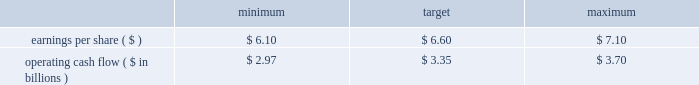The target awards for the other named executive officers were set as follows : joseph f .
Domino , ceo - entergy texas ( 50% ( 50 % ) ) ; hugh t .
Mcdonald , ceo - entergy arkansas ( 50% ( 50 % ) ) ; haley fisackerly , ceo - entergy mississippi ( 40% ( 40 % ) ) ; william m .
Mohl ( 60% ( 60 % ) ) , ceo - entergy gulf states and entergy louisiana ; charles l .
Rice , jr .
( 40% ( 40 % ) ) , ceo - entergy new orleans and theodore h .
Bunting , jr .
- principal accounting officer - the subsidiaries ( 60% ( 60 % ) ) .
The target awards for the named executive officers ( other than entergy named executive officers ) were set by their respective supervisors ( subject to ultimate approval of entergy 2019s chief executive officer ) who allocated a potential incentive pool established by the personnel committee among various of their direct and indirect reports .
In setting the target awards , the supervisor took into account considerations similar to those used by the personnel committee in setting the target awards for entergy 2019s named executive officers .
Target awards are set based on an executive officer 2019s current position and executive management level within the entergy organization .
Executive management levels at entergy range from level 1 thorough level 4 .
Mr .
Denault and mr .
Taylor hold positions in level 2 whereas mr .
Bunting and mr .
Mohl hold positions in level 3 and mr .
Domino , mr .
Fisackerly , mr .
Mcdonald and mr .
Rice hold positions in level 4 .
Accordingly , their respective incentive targets differ one from another based on the external market data developed by the committee 2019s independent compensation consultant and the other factors noted above .
In december 2010 , the committee determined the executive incentive plan targets to be used for purposes of establishing annual bonuses for 2011 .
The committee 2019s determination of the target levels was made after full board review of management 2019s 2011 financial plan for entergy corporation , upon recommendation of the finance committee , and after the committee 2019s determination that the established targets aligned with entergy corporation 2019s anticipated 2011 financial performance as reflected in the financial plan .
The targets established to measure management performance against as reported results were: .
Operating cash flow ( $ in billions ) in january 2012 , after reviewing earnings per share and operating cash flow results against the performance objectives in the above table , the committee determined that entergy corporation had exceeded as reported earnings per share target of $ 6.60 by $ 0.95 in 2011 while falling short of the operating cash flow goal of $ 3.35 billion by $ 221 million in 2011 .
In accordance with the terms of the annual incentive plan , in january 2012 , the personnel committee certified the 2012 entergy achievement multiplier at 128% ( 128 % ) of target .
Under the terms of the management effectiveness program , the entergy achievement multiplier is automatically increased by 25 percent for the members of the office of the chief executive if the pre- established underlying performance goals established by the personnel committee are satisfied at the end of the performance period , subject to the personnel committee's discretion to adjust the automatic multiplier downward or eliminate it altogether .
In accordance with section 162 ( m ) of the internal revenue code , the multiplier which entergy refers to as the management effectiveness factor is intended to provide the committee a mechanism to take into consideration specific achievement factors relating to the overall performance of entergy corporation .
In january 2012 , the committee eliminated the management effectiveness factor with respect to the 2011 incentive awards , reflecting the personnel committee's determination that the entergy achievement multiplier , in and of itself without the management effectiveness factor , was consistent with the performance levels achieved by management .
The annual incentive awards for the named executive officers ( other than mr .
Leonard , mr .
Denault and mr .
Taylor ) are awarded from an incentive pool approved by the committee .
From this pool , each named executive officer 2019s supervisor determines the annual incentive payment based on the entergy achievement multiplier .
The supervisor has the discretion to increase or decrease the multiple used to determine an incentive award based on individual and business unit performance .
The incentive awards are subject to the ultimate approval of entergy 2019s chief executive officer. .
What was the percent of the entergy corporation cash flow shortfall from the target determined in 2011? 
Computations: (221 / 3.35)
Answer: 65.97015. The target awards for the other named executive officers were set as follows : joseph f .
Domino , ceo - entergy texas ( 50% ( 50 % ) ) ; hugh t .
Mcdonald , ceo - entergy arkansas ( 50% ( 50 % ) ) ; haley fisackerly , ceo - entergy mississippi ( 40% ( 40 % ) ) ; william m .
Mohl ( 60% ( 60 % ) ) , ceo - entergy gulf states and entergy louisiana ; charles l .
Rice , jr .
( 40% ( 40 % ) ) , ceo - entergy new orleans and theodore h .
Bunting , jr .
- principal accounting officer - the subsidiaries ( 60% ( 60 % ) ) .
The target awards for the named executive officers ( other than entergy named executive officers ) were set by their respective supervisors ( subject to ultimate approval of entergy 2019s chief executive officer ) who allocated a potential incentive pool established by the personnel committee among various of their direct and indirect reports .
In setting the target awards , the supervisor took into account considerations similar to those used by the personnel committee in setting the target awards for entergy 2019s named executive officers .
Target awards are set based on an executive officer 2019s current position and executive management level within the entergy organization .
Executive management levels at entergy range from level 1 thorough level 4 .
Mr .
Denault and mr .
Taylor hold positions in level 2 whereas mr .
Bunting and mr .
Mohl hold positions in level 3 and mr .
Domino , mr .
Fisackerly , mr .
Mcdonald and mr .
Rice hold positions in level 4 .
Accordingly , their respective incentive targets differ one from another based on the external market data developed by the committee 2019s independent compensation consultant and the other factors noted above .
In december 2010 , the committee determined the executive incentive plan targets to be used for purposes of establishing annual bonuses for 2011 .
The committee 2019s determination of the target levels was made after full board review of management 2019s 2011 financial plan for entergy corporation , upon recommendation of the finance committee , and after the committee 2019s determination that the established targets aligned with entergy corporation 2019s anticipated 2011 financial performance as reflected in the financial plan .
The targets established to measure management performance against as reported results were: .
Operating cash flow ( $ in billions ) in january 2012 , after reviewing earnings per share and operating cash flow results against the performance objectives in the above table , the committee determined that entergy corporation had exceeded as reported earnings per share target of $ 6.60 by $ 0.95 in 2011 while falling short of the operating cash flow goal of $ 3.35 billion by $ 221 million in 2011 .
In accordance with the terms of the annual incentive plan , in january 2012 , the personnel committee certified the 2012 entergy achievement multiplier at 128% ( 128 % ) of target .
Under the terms of the management effectiveness program , the entergy achievement multiplier is automatically increased by 25 percent for the members of the office of the chief executive if the pre- established underlying performance goals established by the personnel committee are satisfied at the end of the performance period , subject to the personnel committee's discretion to adjust the automatic multiplier downward or eliminate it altogether .
In accordance with section 162 ( m ) of the internal revenue code , the multiplier which entergy refers to as the management effectiveness factor is intended to provide the committee a mechanism to take into consideration specific achievement factors relating to the overall performance of entergy corporation .
In january 2012 , the committee eliminated the management effectiveness factor with respect to the 2011 incentive awards , reflecting the personnel committee's determination that the entergy achievement multiplier , in and of itself without the management effectiveness factor , was consistent with the performance levels achieved by management .
The annual incentive awards for the named executive officers ( other than mr .
Leonard , mr .
Denault and mr .
Taylor ) are awarded from an incentive pool approved by the committee .
From this pool , each named executive officer 2019s supervisor determines the annual incentive payment based on the entergy achievement multiplier .
The supervisor has the discretion to increase or decrease the multiple used to determine an incentive award based on individual and business unit performance .
The incentive awards are subject to the ultimate approval of entergy 2019s chief executive officer. .
What is actual earnings per share reported for 2011? 
Computations: (6.60 + 0.95)
Answer: 7.55. 